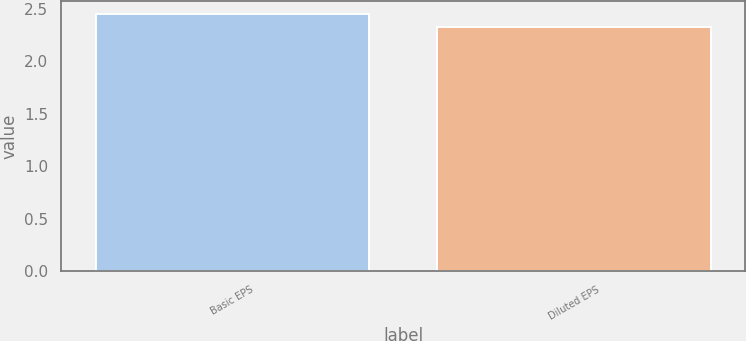Convert chart to OTSL. <chart><loc_0><loc_0><loc_500><loc_500><bar_chart><fcel>Basic EPS<fcel>Diluted EPS<nl><fcel>2.45<fcel>2.33<nl></chart> 